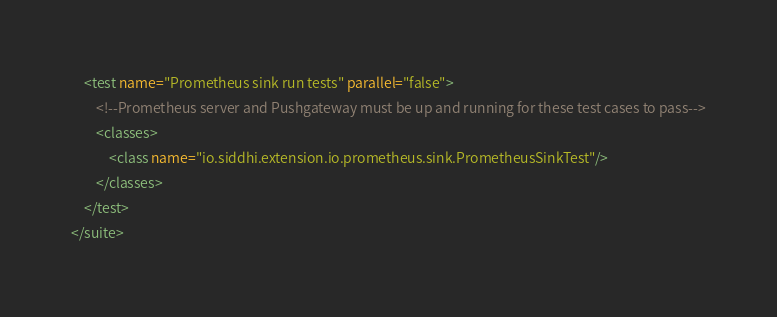Convert code to text. <code><loc_0><loc_0><loc_500><loc_500><_XML_>    <test name="Prometheus sink run tests" parallel="false">
        <!--Prometheus server and Pushgateway must be up and running for these test cases to pass-->
        <classes>
            <class name="io.siddhi.extension.io.prometheus.sink.PrometheusSinkTest"/>
        </classes>
    </test>
</suite></code> 